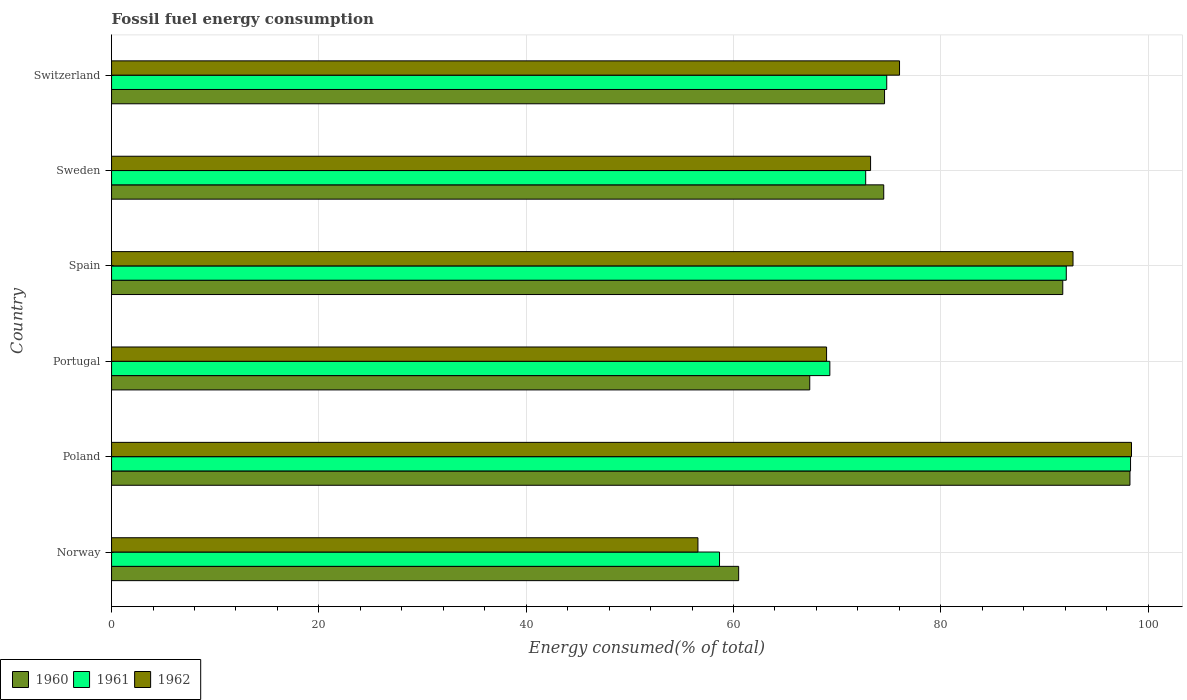Are the number of bars per tick equal to the number of legend labels?
Your answer should be compact. Yes. Are the number of bars on each tick of the Y-axis equal?
Your answer should be compact. Yes. What is the percentage of energy consumed in 1960 in Spain?
Your response must be concise. 91.77. Across all countries, what is the maximum percentage of energy consumed in 1960?
Offer a very short reply. 98.25. Across all countries, what is the minimum percentage of energy consumed in 1962?
Give a very brief answer. 56.57. In which country was the percentage of energy consumed in 1962 minimum?
Your answer should be very brief. Norway. What is the total percentage of energy consumed in 1962 in the graph?
Provide a succinct answer. 465.94. What is the difference between the percentage of energy consumed in 1960 in Spain and that in Switzerland?
Make the answer very short. 17.19. What is the difference between the percentage of energy consumed in 1962 in Norway and the percentage of energy consumed in 1961 in Sweden?
Provide a succinct answer. -16.18. What is the average percentage of energy consumed in 1960 per country?
Keep it short and to the point. 77.82. What is the difference between the percentage of energy consumed in 1960 and percentage of energy consumed in 1961 in Portugal?
Give a very brief answer. -1.94. What is the ratio of the percentage of energy consumed in 1962 in Norway to that in Spain?
Provide a succinct answer. 0.61. Is the difference between the percentage of energy consumed in 1960 in Poland and Portugal greater than the difference between the percentage of energy consumed in 1961 in Poland and Portugal?
Provide a succinct answer. Yes. What is the difference between the highest and the second highest percentage of energy consumed in 1962?
Provide a succinct answer. 5.64. What is the difference between the highest and the lowest percentage of energy consumed in 1960?
Keep it short and to the point. 37.75. What does the 2nd bar from the top in Norway represents?
Your answer should be compact. 1961. Is it the case that in every country, the sum of the percentage of energy consumed in 1960 and percentage of energy consumed in 1962 is greater than the percentage of energy consumed in 1961?
Ensure brevity in your answer.  Yes. How many bars are there?
Provide a succinct answer. 18. Are all the bars in the graph horizontal?
Provide a succinct answer. Yes. How many countries are there in the graph?
Provide a succinct answer. 6. Does the graph contain any zero values?
Provide a succinct answer. No. Does the graph contain grids?
Offer a very short reply. Yes. Where does the legend appear in the graph?
Make the answer very short. Bottom left. How are the legend labels stacked?
Your response must be concise. Horizontal. What is the title of the graph?
Offer a very short reply. Fossil fuel energy consumption. Does "2012" appear as one of the legend labels in the graph?
Offer a very short reply. No. What is the label or title of the X-axis?
Make the answer very short. Energy consumed(% of total). What is the Energy consumed(% of total) of 1960 in Norway?
Your answer should be compact. 60.5. What is the Energy consumed(% of total) of 1961 in Norway?
Offer a very short reply. 58.65. What is the Energy consumed(% of total) in 1962 in Norway?
Ensure brevity in your answer.  56.57. What is the Energy consumed(% of total) in 1960 in Poland?
Your answer should be very brief. 98.25. What is the Energy consumed(% of total) in 1961 in Poland?
Offer a terse response. 98.3. What is the Energy consumed(% of total) of 1962 in Poland?
Provide a short and direct response. 98.4. What is the Energy consumed(% of total) in 1960 in Portugal?
Offer a terse response. 67.36. What is the Energy consumed(% of total) in 1961 in Portugal?
Your response must be concise. 69.3. What is the Energy consumed(% of total) in 1962 in Portugal?
Make the answer very short. 68.98. What is the Energy consumed(% of total) of 1960 in Spain?
Provide a succinct answer. 91.77. What is the Energy consumed(% of total) in 1961 in Spain?
Provide a succinct answer. 92.1. What is the Energy consumed(% of total) in 1962 in Spain?
Your response must be concise. 92.75. What is the Energy consumed(% of total) in 1960 in Sweden?
Your answer should be very brief. 74.49. What is the Energy consumed(% of total) in 1961 in Sweden?
Ensure brevity in your answer.  72.75. What is the Energy consumed(% of total) of 1962 in Sweden?
Make the answer very short. 73.23. What is the Energy consumed(% of total) of 1960 in Switzerland?
Provide a short and direct response. 74.57. What is the Energy consumed(% of total) of 1961 in Switzerland?
Your answer should be compact. 74.78. What is the Energy consumed(% of total) of 1962 in Switzerland?
Your response must be concise. 76.02. Across all countries, what is the maximum Energy consumed(% of total) of 1960?
Provide a succinct answer. 98.25. Across all countries, what is the maximum Energy consumed(% of total) in 1961?
Offer a very short reply. 98.3. Across all countries, what is the maximum Energy consumed(% of total) in 1962?
Your response must be concise. 98.4. Across all countries, what is the minimum Energy consumed(% of total) of 1960?
Offer a terse response. 60.5. Across all countries, what is the minimum Energy consumed(% of total) in 1961?
Make the answer very short. 58.65. Across all countries, what is the minimum Energy consumed(% of total) of 1962?
Make the answer very short. 56.57. What is the total Energy consumed(% of total) in 1960 in the graph?
Provide a short and direct response. 466.93. What is the total Energy consumed(% of total) of 1961 in the graph?
Your answer should be compact. 465.89. What is the total Energy consumed(% of total) in 1962 in the graph?
Provide a short and direct response. 465.94. What is the difference between the Energy consumed(% of total) of 1960 in Norway and that in Poland?
Give a very brief answer. -37.75. What is the difference between the Energy consumed(% of total) of 1961 in Norway and that in Poland?
Ensure brevity in your answer.  -39.65. What is the difference between the Energy consumed(% of total) of 1962 in Norway and that in Poland?
Your response must be concise. -41.83. What is the difference between the Energy consumed(% of total) in 1960 in Norway and that in Portugal?
Provide a short and direct response. -6.86. What is the difference between the Energy consumed(% of total) in 1961 in Norway and that in Portugal?
Provide a succinct answer. -10.64. What is the difference between the Energy consumed(% of total) in 1962 in Norway and that in Portugal?
Your answer should be compact. -12.41. What is the difference between the Energy consumed(% of total) of 1960 in Norway and that in Spain?
Your answer should be very brief. -31.27. What is the difference between the Energy consumed(% of total) in 1961 in Norway and that in Spain?
Your answer should be very brief. -33.45. What is the difference between the Energy consumed(% of total) in 1962 in Norway and that in Spain?
Your response must be concise. -36.18. What is the difference between the Energy consumed(% of total) of 1960 in Norway and that in Sweden?
Your response must be concise. -14. What is the difference between the Energy consumed(% of total) of 1961 in Norway and that in Sweden?
Provide a short and direct response. -14.1. What is the difference between the Energy consumed(% of total) in 1962 in Norway and that in Sweden?
Offer a terse response. -16.66. What is the difference between the Energy consumed(% of total) of 1960 in Norway and that in Switzerland?
Give a very brief answer. -14.07. What is the difference between the Energy consumed(% of total) of 1961 in Norway and that in Switzerland?
Keep it short and to the point. -16.13. What is the difference between the Energy consumed(% of total) of 1962 in Norway and that in Switzerland?
Make the answer very short. -19.45. What is the difference between the Energy consumed(% of total) of 1960 in Poland and that in Portugal?
Offer a terse response. 30.89. What is the difference between the Energy consumed(% of total) in 1961 in Poland and that in Portugal?
Offer a terse response. 29.01. What is the difference between the Energy consumed(% of total) of 1962 in Poland and that in Portugal?
Give a very brief answer. 29.42. What is the difference between the Energy consumed(% of total) in 1960 in Poland and that in Spain?
Offer a terse response. 6.48. What is the difference between the Energy consumed(% of total) of 1961 in Poland and that in Spain?
Your response must be concise. 6.2. What is the difference between the Energy consumed(% of total) of 1962 in Poland and that in Spain?
Make the answer very short. 5.64. What is the difference between the Energy consumed(% of total) of 1960 in Poland and that in Sweden?
Your answer should be compact. 23.75. What is the difference between the Energy consumed(% of total) in 1961 in Poland and that in Sweden?
Your answer should be compact. 25.55. What is the difference between the Energy consumed(% of total) of 1962 in Poland and that in Sweden?
Provide a succinct answer. 25.17. What is the difference between the Energy consumed(% of total) of 1960 in Poland and that in Switzerland?
Provide a succinct answer. 23.67. What is the difference between the Energy consumed(% of total) of 1961 in Poland and that in Switzerland?
Your answer should be compact. 23.52. What is the difference between the Energy consumed(% of total) in 1962 in Poland and that in Switzerland?
Provide a short and direct response. 22.38. What is the difference between the Energy consumed(% of total) of 1960 in Portugal and that in Spain?
Provide a succinct answer. -24.41. What is the difference between the Energy consumed(% of total) of 1961 in Portugal and that in Spain?
Offer a very short reply. -22.81. What is the difference between the Energy consumed(% of total) in 1962 in Portugal and that in Spain?
Offer a very short reply. -23.77. What is the difference between the Energy consumed(% of total) of 1960 in Portugal and that in Sweden?
Keep it short and to the point. -7.14. What is the difference between the Energy consumed(% of total) in 1961 in Portugal and that in Sweden?
Your answer should be very brief. -3.46. What is the difference between the Energy consumed(% of total) of 1962 in Portugal and that in Sweden?
Provide a succinct answer. -4.25. What is the difference between the Energy consumed(% of total) of 1960 in Portugal and that in Switzerland?
Offer a very short reply. -7.22. What is the difference between the Energy consumed(% of total) of 1961 in Portugal and that in Switzerland?
Keep it short and to the point. -5.49. What is the difference between the Energy consumed(% of total) in 1962 in Portugal and that in Switzerland?
Offer a very short reply. -7.04. What is the difference between the Energy consumed(% of total) of 1960 in Spain and that in Sweden?
Provide a succinct answer. 17.27. What is the difference between the Energy consumed(% of total) of 1961 in Spain and that in Sweden?
Your answer should be compact. 19.35. What is the difference between the Energy consumed(% of total) of 1962 in Spain and that in Sweden?
Your answer should be compact. 19.53. What is the difference between the Energy consumed(% of total) of 1960 in Spain and that in Switzerland?
Your answer should be compact. 17.19. What is the difference between the Energy consumed(% of total) in 1961 in Spain and that in Switzerland?
Your answer should be compact. 17.32. What is the difference between the Energy consumed(% of total) in 1962 in Spain and that in Switzerland?
Keep it short and to the point. 16.74. What is the difference between the Energy consumed(% of total) in 1960 in Sweden and that in Switzerland?
Provide a short and direct response. -0.08. What is the difference between the Energy consumed(% of total) in 1961 in Sweden and that in Switzerland?
Ensure brevity in your answer.  -2.03. What is the difference between the Energy consumed(% of total) of 1962 in Sweden and that in Switzerland?
Your answer should be very brief. -2.79. What is the difference between the Energy consumed(% of total) of 1960 in Norway and the Energy consumed(% of total) of 1961 in Poland?
Keep it short and to the point. -37.81. What is the difference between the Energy consumed(% of total) in 1960 in Norway and the Energy consumed(% of total) in 1962 in Poland?
Your response must be concise. -37.9. What is the difference between the Energy consumed(% of total) in 1961 in Norway and the Energy consumed(% of total) in 1962 in Poland?
Your answer should be very brief. -39.74. What is the difference between the Energy consumed(% of total) of 1960 in Norway and the Energy consumed(% of total) of 1961 in Portugal?
Offer a terse response. -8.8. What is the difference between the Energy consumed(% of total) of 1960 in Norway and the Energy consumed(% of total) of 1962 in Portugal?
Offer a very short reply. -8.48. What is the difference between the Energy consumed(% of total) of 1961 in Norway and the Energy consumed(% of total) of 1962 in Portugal?
Offer a terse response. -10.33. What is the difference between the Energy consumed(% of total) in 1960 in Norway and the Energy consumed(% of total) in 1961 in Spain?
Ensure brevity in your answer.  -31.61. What is the difference between the Energy consumed(% of total) of 1960 in Norway and the Energy consumed(% of total) of 1962 in Spain?
Ensure brevity in your answer.  -32.26. What is the difference between the Energy consumed(% of total) in 1961 in Norway and the Energy consumed(% of total) in 1962 in Spain?
Provide a short and direct response. -34.1. What is the difference between the Energy consumed(% of total) of 1960 in Norway and the Energy consumed(% of total) of 1961 in Sweden?
Your answer should be compact. -12.26. What is the difference between the Energy consumed(% of total) in 1960 in Norway and the Energy consumed(% of total) in 1962 in Sweden?
Ensure brevity in your answer.  -12.73. What is the difference between the Energy consumed(% of total) in 1961 in Norway and the Energy consumed(% of total) in 1962 in Sweden?
Give a very brief answer. -14.57. What is the difference between the Energy consumed(% of total) of 1960 in Norway and the Energy consumed(% of total) of 1961 in Switzerland?
Offer a very short reply. -14.29. What is the difference between the Energy consumed(% of total) of 1960 in Norway and the Energy consumed(% of total) of 1962 in Switzerland?
Provide a succinct answer. -15.52. What is the difference between the Energy consumed(% of total) in 1961 in Norway and the Energy consumed(% of total) in 1962 in Switzerland?
Make the answer very short. -17.37. What is the difference between the Energy consumed(% of total) in 1960 in Poland and the Energy consumed(% of total) in 1961 in Portugal?
Provide a short and direct response. 28.95. What is the difference between the Energy consumed(% of total) in 1960 in Poland and the Energy consumed(% of total) in 1962 in Portugal?
Provide a succinct answer. 29.27. What is the difference between the Energy consumed(% of total) in 1961 in Poland and the Energy consumed(% of total) in 1962 in Portugal?
Keep it short and to the point. 29.32. What is the difference between the Energy consumed(% of total) of 1960 in Poland and the Energy consumed(% of total) of 1961 in Spain?
Offer a very short reply. 6.14. What is the difference between the Energy consumed(% of total) in 1960 in Poland and the Energy consumed(% of total) in 1962 in Spain?
Give a very brief answer. 5.49. What is the difference between the Energy consumed(% of total) of 1961 in Poland and the Energy consumed(% of total) of 1962 in Spain?
Your response must be concise. 5.55. What is the difference between the Energy consumed(% of total) in 1960 in Poland and the Energy consumed(% of total) in 1961 in Sweden?
Your answer should be very brief. 25.49. What is the difference between the Energy consumed(% of total) in 1960 in Poland and the Energy consumed(% of total) in 1962 in Sweden?
Provide a succinct answer. 25.02. What is the difference between the Energy consumed(% of total) in 1961 in Poland and the Energy consumed(% of total) in 1962 in Sweden?
Your answer should be very brief. 25.08. What is the difference between the Energy consumed(% of total) in 1960 in Poland and the Energy consumed(% of total) in 1961 in Switzerland?
Offer a terse response. 23.46. What is the difference between the Energy consumed(% of total) in 1960 in Poland and the Energy consumed(% of total) in 1962 in Switzerland?
Offer a terse response. 22.23. What is the difference between the Energy consumed(% of total) in 1961 in Poland and the Energy consumed(% of total) in 1962 in Switzerland?
Your answer should be compact. 22.29. What is the difference between the Energy consumed(% of total) in 1960 in Portugal and the Energy consumed(% of total) in 1961 in Spain?
Give a very brief answer. -24.75. What is the difference between the Energy consumed(% of total) of 1960 in Portugal and the Energy consumed(% of total) of 1962 in Spain?
Keep it short and to the point. -25.4. What is the difference between the Energy consumed(% of total) of 1961 in Portugal and the Energy consumed(% of total) of 1962 in Spain?
Your answer should be very brief. -23.46. What is the difference between the Energy consumed(% of total) of 1960 in Portugal and the Energy consumed(% of total) of 1961 in Sweden?
Provide a short and direct response. -5.4. What is the difference between the Energy consumed(% of total) of 1960 in Portugal and the Energy consumed(% of total) of 1962 in Sweden?
Your response must be concise. -5.87. What is the difference between the Energy consumed(% of total) in 1961 in Portugal and the Energy consumed(% of total) in 1962 in Sweden?
Ensure brevity in your answer.  -3.93. What is the difference between the Energy consumed(% of total) of 1960 in Portugal and the Energy consumed(% of total) of 1961 in Switzerland?
Make the answer very short. -7.43. What is the difference between the Energy consumed(% of total) of 1960 in Portugal and the Energy consumed(% of total) of 1962 in Switzerland?
Provide a succinct answer. -8.66. What is the difference between the Energy consumed(% of total) in 1961 in Portugal and the Energy consumed(% of total) in 1962 in Switzerland?
Keep it short and to the point. -6.72. What is the difference between the Energy consumed(% of total) in 1960 in Spain and the Energy consumed(% of total) in 1961 in Sweden?
Provide a short and direct response. 19.01. What is the difference between the Energy consumed(% of total) of 1960 in Spain and the Energy consumed(% of total) of 1962 in Sweden?
Your answer should be compact. 18.54. What is the difference between the Energy consumed(% of total) of 1961 in Spain and the Energy consumed(% of total) of 1962 in Sweden?
Offer a very short reply. 18.88. What is the difference between the Energy consumed(% of total) of 1960 in Spain and the Energy consumed(% of total) of 1961 in Switzerland?
Your answer should be compact. 16.98. What is the difference between the Energy consumed(% of total) in 1960 in Spain and the Energy consumed(% of total) in 1962 in Switzerland?
Ensure brevity in your answer.  15.75. What is the difference between the Energy consumed(% of total) of 1961 in Spain and the Energy consumed(% of total) of 1962 in Switzerland?
Provide a short and direct response. 16.09. What is the difference between the Energy consumed(% of total) in 1960 in Sweden and the Energy consumed(% of total) in 1961 in Switzerland?
Your answer should be very brief. -0.29. What is the difference between the Energy consumed(% of total) of 1960 in Sweden and the Energy consumed(% of total) of 1962 in Switzerland?
Make the answer very short. -1.52. What is the difference between the Energy consumed(% of total) of 1961 in Sweden and the Energy consumed(% of total) of 1962 in Switzerland?
Give a very brief answer. -3.26. What is the average Energy consumed(% of total) of 1960 per country?
Your answer should be very brief. 77.82. What is the average Energy consumed(% of total) of 1961 per country?
Keep it short and to the point. 77.65. What is the average Energy consumed(% of total) of 1962 per country?
Your answer should be very brief. 77.66. What is the difference between the Energy consumed(% of total) of 1960 and Energy consumed(% of total) of 1961 in Norway?
Provide a succinct answer. 1.85. What is the difference between the Energy consumed(% of total) in 1960 and Energy consumed(% of total) in 1962 in Norway?
Provide a succinct answer. 3.93. What is the difference between the Energy consumed(% of total) in 1961 and Energy consumed(% of total) in 1962 in Norway?
Your answer should be very brief. 2.08. What is the difference between the Energy consumed(% of total) of 1960 and Energy consumed(% of total) of 1961 in Poland?
Your answer should be compact. -0.06. What is the difference between the Energy consumed(% of total) in 1960 and Energy consumed(% of total) in 1962 in Poland?
Provide a short and direct response. -0.15. What is the difference between the Energy consumed(% of total) of 1961 and Energy consumed(% of total) of 1962 in Poland?
Your answer should be compact. -0.09. What is the difference between the Energy consumed(% of total) in 1960 and Energy consumed(% of total) in 1961 in Portugal?
Keep it short and to the point. -1.94. What is the difference between the Energy consumed(% of total) of 1960 and Energy consumed(% of total) of 1962 in Portugal?
Offer a terse response. -1.62. What is the difference between the Energy consumed(% of total) of 1961 and Energy consumed(% of total) of 1962 in Portugal?
Provide a short and direct response. 0.32. What is the difference between the Energy consumed(% of total) in 1960 and Energy consumed(% of total) in 1961 in Spain?
Provide a succinct answer. -0.34. What is the difference between the Energy consumed(% of total) in 1960 and Energy consumed(% of total) in 1962 in Spain?
Give a very brief answer. -0.99. What is the difference between the Energy consumed(% of total) in 1961 and Energy consumed(% of total) in 1962 in Spain?
Ensure brevity in your answer.  -0.65. What is the difference between the Energy consumed(% of total) in 1960 and Energy consumed(% of total) in 1961 in Sweden?
Provide a succinct answer. 1.74. What is the difference between the Energy consumed(% of total) of 1960 and Energy consumed(% of total) of 1962 in Sweden?
Offer a very short reply. 1.27. What is the difference between the Energy consumed(% of total) in 1961 and Energy consumed(% of total) in 1962 in Sweden?
Ensure brevity in your answer.  -0.47. What is the difference between the Energy consumed(% of total) in 1960 and Energy consumed(% of total) in 1961 in Switzerland?
Your response must be concise. -0.21. What is the difference between the Energy consumed(% of total) of 1960 and Energy consumed(% of total) of 1962 in Switzerland?
Make the answer very short. -1.45. What is the difference between the Energy consumed(% of total) in 1961 and Energy consumed(% of total) in 1962 in Switzerland?
Ensure brevity in your answer.  -1.23. What is the ratio of the Energy consumed(% of total) of 1960 in Norway to that in Poland?
Make the answer very short. 0.62. What is the ratio of the Energy consumed(% of total) of 1961 in Norway to that in Poland?
Your response must be concise. 0.6. What is the ratio of the Energy consumed(% of total) of 1962 in Norway to that in Poland?
Offer a very short reply. 0.57. What is the ratio of the Energy consumed(% of total) of 1960 in Norway to that in Portugal?
Offer a terse response. 0.9. What is the ratio of the Energy consumed(% of total) of 1961 in Norway to that in Portugal?
Make the answer very short. 0.85. What is the ratio of the Energy consumed(% of total) in 1962 in Norway to that in Portugal?
Provide a short and direct response. 0.82. What is the ratio of the Energy consumed(% of total) of 1960 in Norway to that in Spain?
Provide a succinct answer. 0.66. What is the ratio of the Energy consumed(% of total) in 1961 in Norway to that in Spain?
Offer a terse response. 0.64. What is the ratio of the Energy consumed(% of total) in 1962 in Norway to that in Spain?
Ensure brevity in your answer.  0.61. What is the ratio of the Energy consumed(% of total) in 1960 in Norway to that in Sweden?
Keep it short and to the point. 0.81. What is the ratio of the Energy consumed(% of total) of 1961 in Norway to that in Sweden?
Your answer should be compact. 0.81. What is the ratio of the Energy consumed(% of total) of 1962 in Norway to that in Sweden?
Your answer should be very brief. 0.77. What is the ratio of the Energy consumed(% of total) of 1960 in Norway to that in Switzerland?
Ensure brevity in your answer.  0.81. What is the ratio of the Energy consumed(% of total) in 1961 in Norway to that in Switzerland?
Ensure brevity in your answer.  0.78. What is the ratio of the Energy consumed(% of total) of 1962 in Norway to that in Switzerland?
Keep it short and to the point. 0.74. What is the ratio of the Energy consumed(% of total) of 1960 in Poland to that in Portugal?
Your answer should be compact. 1.46. What is the ratio of the Energy consumed(% of total) in 1961 in Poland to that in Portugal?
Keep it short and to the point. 1.42. What is the ratio of the Energy consumed(% of total) in 1962 in Poland to that in Portugal?
Your response must be concise. 1.43. What is the ratio of the Energy consumed(% of total) of 1960 in Poland to that in Spain?
Provide a short and direct response. 1.07. What is the ratio of the Energy consumed(% of total) of 1961 in Poland to that in Spain?
Keep it short and to the point. 1.07. What is the ratio of the Energy consumed(% of total) in 1962 in Poland to that in Spain?
Provide a short and direct response. 1.06. What is the ratio of the Energy consumed(% of total) of 1960 in Poland to that in Sweden?
Provide a succinct answer. 1.32. What is the ratio of the Energy consumed(% of total) of 1961 in Poland to that in Sweden?
Offer a very short reply. 1.35. What is the ratio of the Energy consumed(% of total) in 1962 in Poland to that in Sweden?
Your answer should be compact. 1.34. What is the ratio of the Energy consumed(% of total) in 1960 in Poland to that in Switzerland?
Give a very brief answer. 1.32. What is the ratio of the Energy consumed(% of total) of 1961 in Poland to that in Switzerland?
Your answer should be very brief. 1.31. What is the ratio of the Energy consumed(% of total) in 1962 in Poland to that in Switzerland?
Offer a very short reply. 1.29. What is the ratio of the Energy consumed(% of total) in 1960 in Portugal to that in Spain?
Provide a short and direct response. 0.73. What is the ratio of the Energy consumed(% of total) of 1961 in Portugal to that in Spain?
Keep it short and to the point. 0.75. What is the ratio of the Energy consumed(% of total) of 1962 in Portugal to that in Spain?
Offer a very short reply. 0.74. What is the ratio of the Energy consumed(% of total) in 1960 in Portugal to that in Sweden?
Keep it short and to the point. 0.9. What is the ratio of the Energy consumed(% of total) in 1961 in Portugal to that in Sweden?
Offer a very short reply. 0.95. What is the ratio of the Energy consumed(% of total) in 1962 in Portugal to that in Sweden?
Provide a succinct answer. 0.94. What is the ratio of the Energy consumed(% of total) in 1960 in Portugal to that in Switzerland?
Provide a succinct answer. 0.9. What is the ratio of the Energy consumed(% of total) of 1961 in Portugal to that in Switzerland?
Offer a very short reply. 0.93. What is the ratio of the Energy consumed(% of total) in 1962 in Portugal to that in Switzerland?
Your answer should be very brief. 0.91. What is the ratio of the Energy consumed(% of total) of 1960 in Spain to that in Sweden?
Your answer should be very brief. 1.23. What is the ratio of the Energy consumed(% of total) in 1961 in Spain to that in Sweden?
Your answer should be compact. 1.27. What is the ratio of the Energy consumed(% of total) of 1962 in Spain to that in Sweden?
Keep it short and to the point. 1.27. What is the ratio of the Energy consumed(% of total) of 1960 in Spain to that in Switzerland?
Provide a succinct answer. 1.23. What is the ratio of the Energy consumed(% of total) of 1961 in Spain to that in Switzerland?
Make the answer very short. 1.23. What is the ratio of the Energy consumed(% of total) of 1962 in Spain to that in Switzerland?
Make the answer very short. 1.22. What is the ratio of the Energy consumed(% of total) of 1961 in Sweden to that in Switzerland?
Offer a terse response. 0.97. What is the ratio of the Energy consumed(% of total) of 1962 in Sweden to that in Switzerland?
Your answer should be compact. 0.96. What is the difference between the highest and the second highest Energy consumed(% of total) of 1960?
Your response must be concise. 6.48. What is the difference between the highest and the second highest Energy consumed(% of total) in 1961?
Make the answer very short. 6.2. What is the difference between the highest and the second highest Energy consumed(% of total) of 1962?
Offer a terse response. 5.64. What is the difference between the highest and the lowest Energy consumed(% of total) of 1960?
Offer a very short reply. 37.75. What is the difference between the highest and the lowest Energy consumed(% of total) in 1961?
Keep it short and to the point. 39.65. What is the difference between the highest and the lowest Energy consumed(% of total) in 1962?
Give a very brief answer. 41.83. 